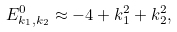<formula> <loc_0><loc_0><loc_500><loc_500>E _ { k _ { 1 } , k _ { 2 } } ^ { 0 } \approx - 4 + k _ { 1 } ^ { 2 } + k _ { 2 } ^ { 2 } ,</formula> 